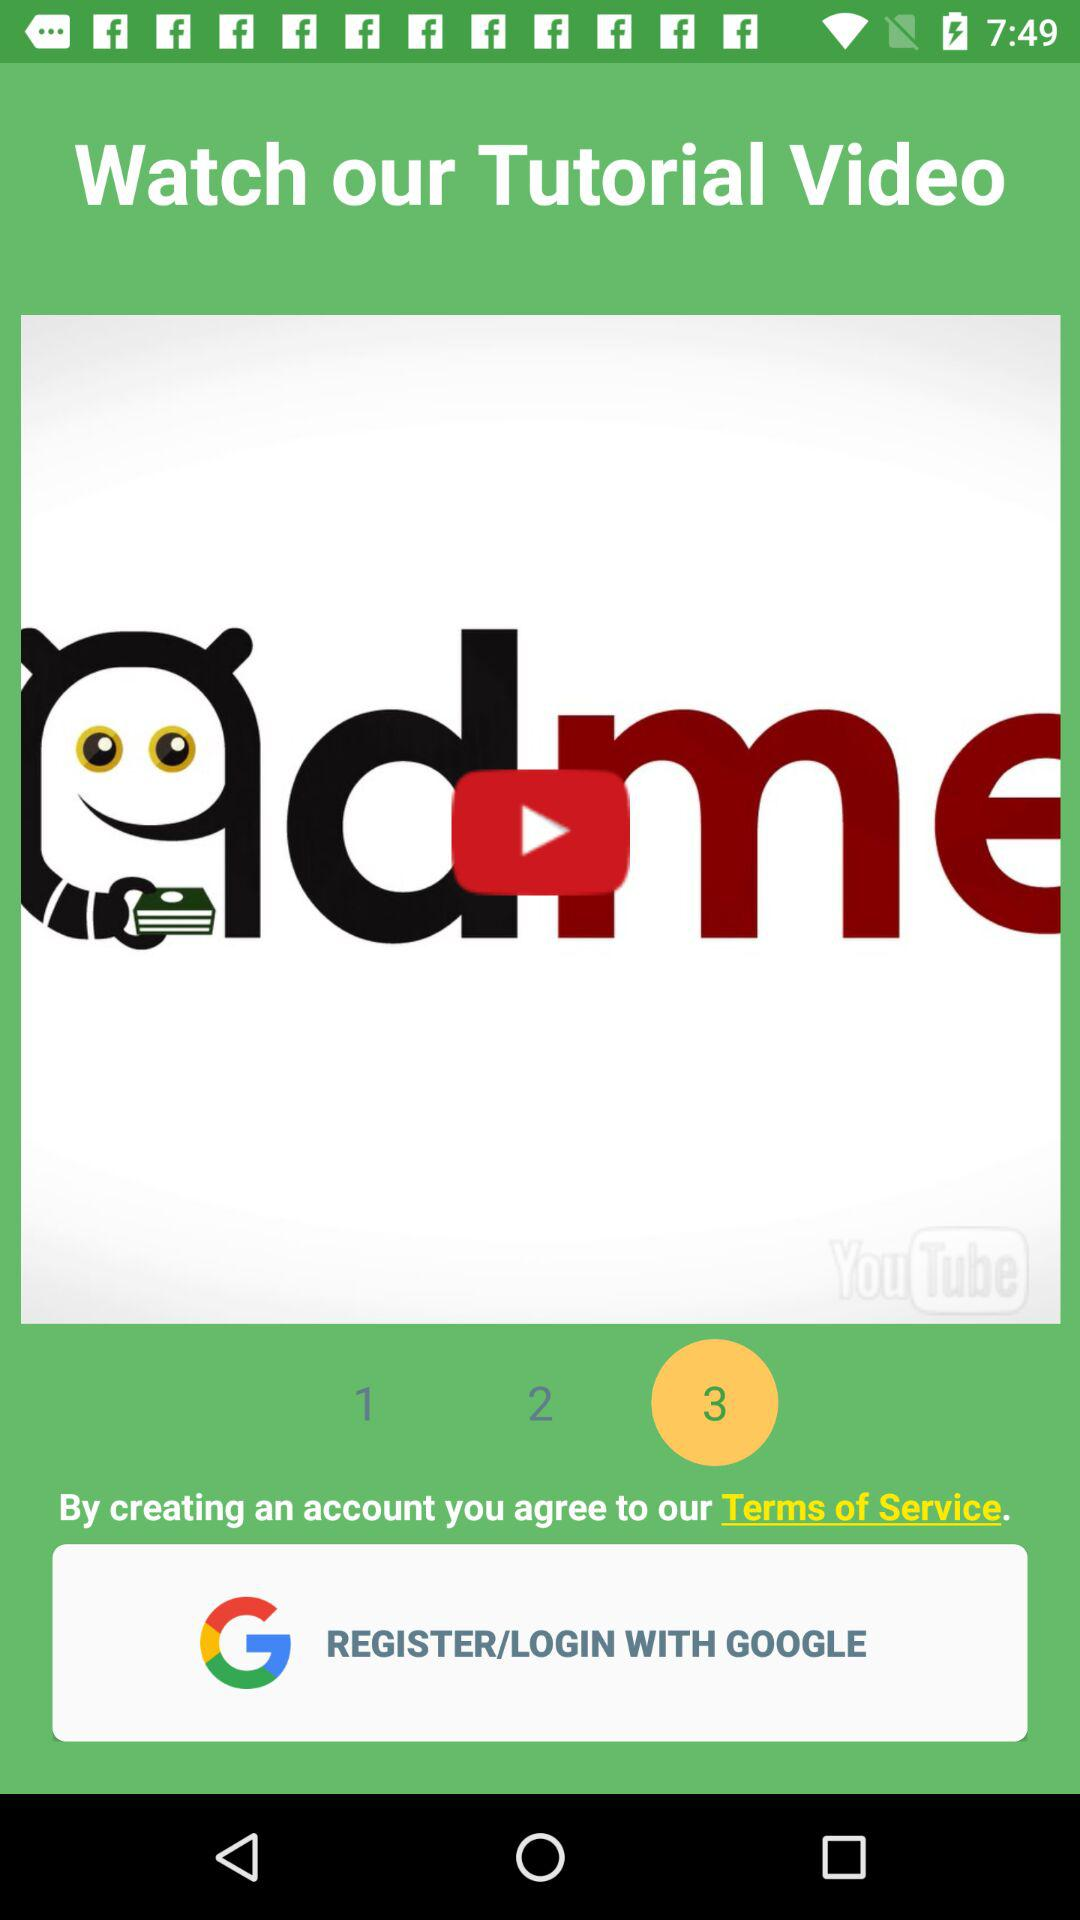Through what applications can we log in or register? The application is "GOOGLE". 